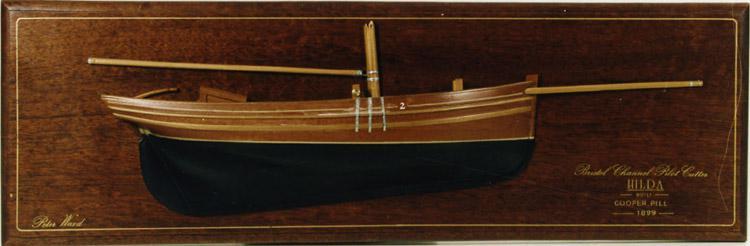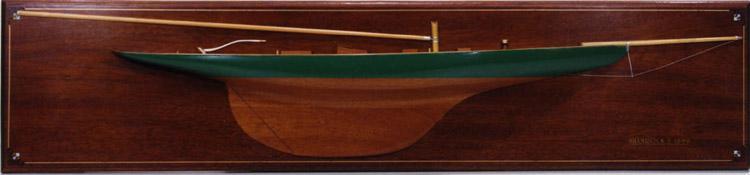The first image is the image on the left, the second image is the image on the right. For the images displayed, is the sentence "The right image shows a model ship on a wooden plaque." factually correct? Answer yes or no. Yes. The first image is the image on the left, the second image is the image on the right. Analyze the images presented: Is the assertion "An image shows at least one undocked boat surrounded by water." valid? Answer yes or no. No. 